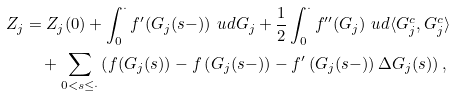Convert formula to latex. <formula><loc_0><loc_0><loc_500><loc_500>Z _ { j } & = Z _ { j } ( 0 ) + \int _ { 0 } ^ { \cdot } f ^ { \prime } ( G _ { j } ( s - ) ) \ u d G _ { j } + \frac { 1 } { 2 } \int _ { 0 } ^ { \cdot } f ^ { \prime \prime } ( G _ { j } ) \ u d \langle G _ { j } ^ { c } , G _ { j } ^ { c } \rangle \\ & \quad + \sum _ { 0 < s \leq \cdot } \left ( f ( G _ { j } ( s ) ) - f \left ( G _ { j } ( s - ) \right ) - f ^ { \prime } \left ( G _ { j } ( s - ) \right ) \Delta G _ { j } ( s ) \right ) ,</formula> 